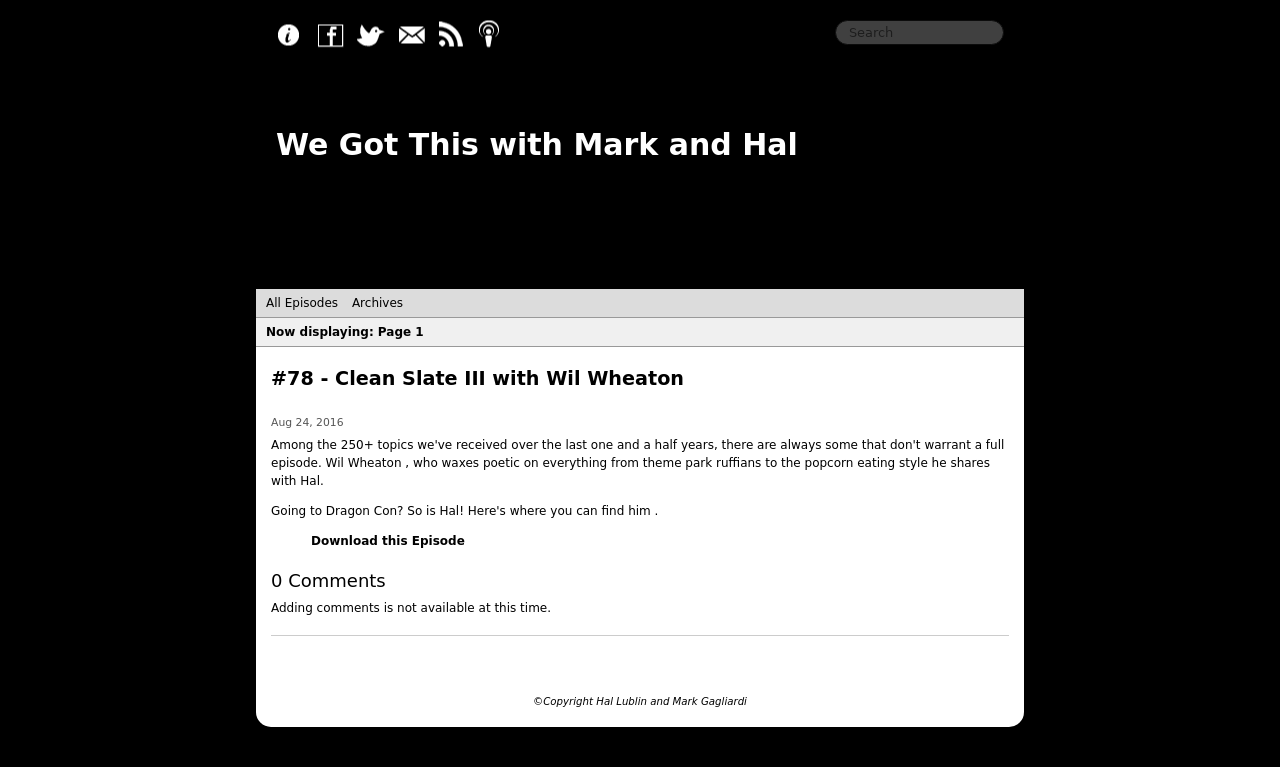Could you guide me through the process of developing this website with HTML? Absolutely, to start developing a website like the one in the image, you would begin with the structure using HTML. First, organize your content into sections like header, main content area, and footer. Use semantic tags like <header>, <main>, <section>, and <footer> to mark these up. Inside, you can place elements like <h1> for your main titles, <p> for paragraphs, and <a> for links. Don't forget to define your document type at the beginning with <!DOCTYPE html> and include meta tags within the <head> section to ensure your site is responsive and well-formatted across different devices. 